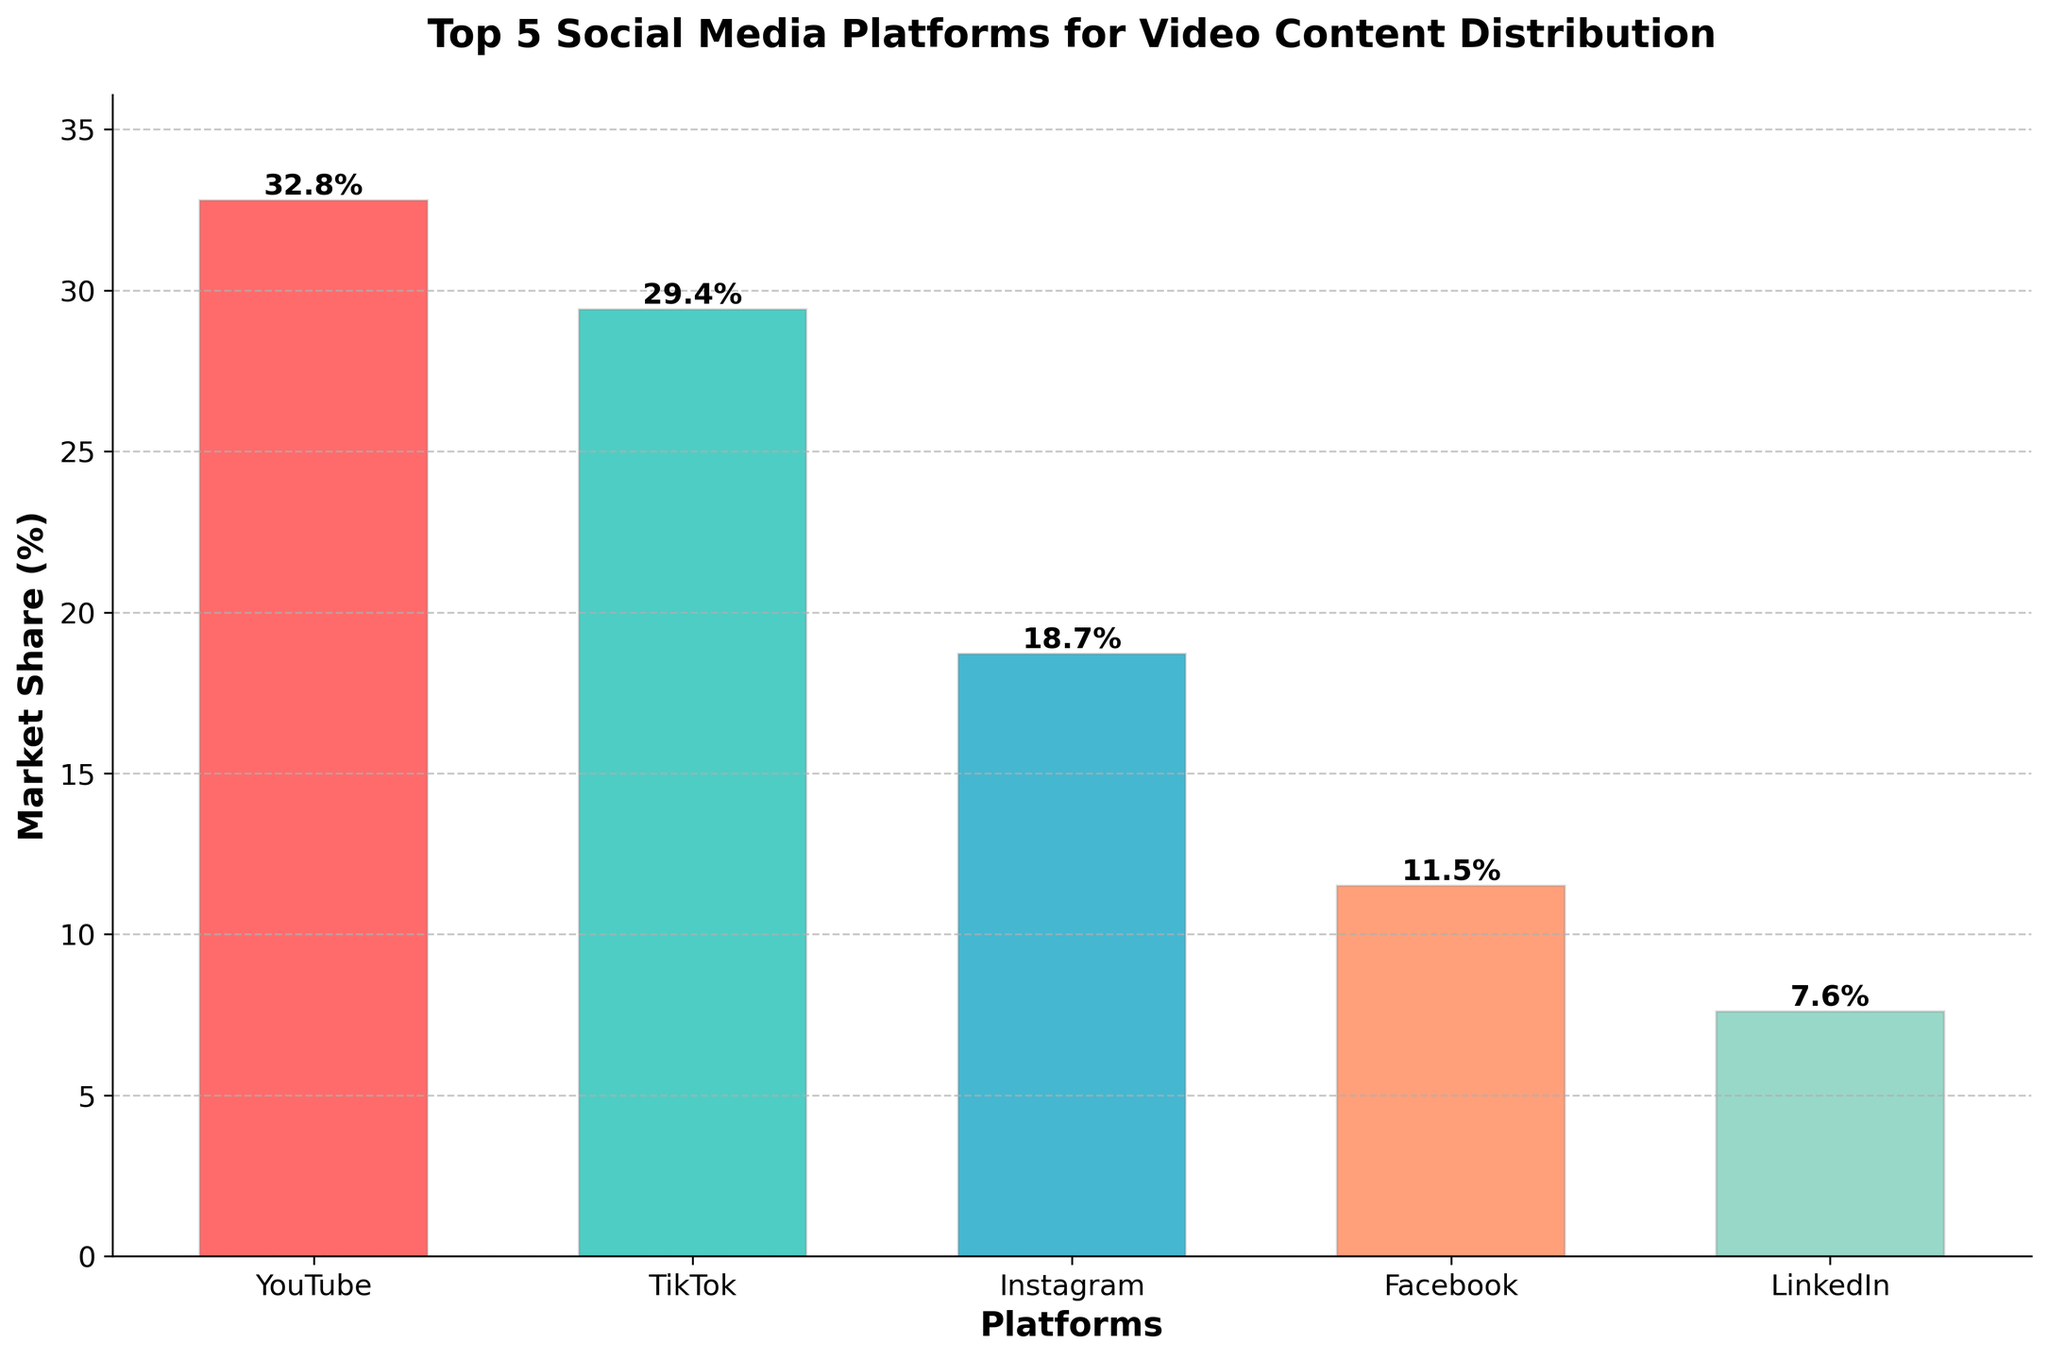What's the total market share of YouTube and TikTok combined? To find the total market share of YouTube and TikTok, add their respective market shares: 32.8% (YouTube) + 29.4% (TikTok) = 62.2%.
Answer: 62.2% Which platform has the lowest market share? From the figure, LinkedIn has the smallest bar, representing the lowest market share of 7.6%.
Answer: LinkedIn What is the difference in market share between the highest and lowest-ranked platforms? The highest market share is 32.8% for YouTube and the lowest is 7.6% for LinkedIn. Subtracting these gives: 32.8% - 7.6% = 25.2%.
Answer: 25.2% Which platform has a higher market share: Instagram or Facebook? By examining the heights of the bars, Instagram with an 18.7% market share is higher than Facebook's 11.5%.
Answer: Instagram What's the average market share of the top 5 platforms? First, sum the market shares: 32.8% (YouTube) + 29.4% (TikTok) + 18.7% (Instagram) + 11.5% (Facebook) + 7.6% (LinkedIn) = 100%. Then divide by the number of platforms: 100% / 5 = 20%.
Answer: 20% What is the combined market share of the platforms with a market share under 20%? The platforms under 20% are: Instagram (18.7%), Facebook (11.5%), and LinkedIn (7.6%). Adding these gives: 18.7% + 11.5% + 7.6% = 37.8%.
Answer: 37.8% Which platform's bar is orange in color? The color scheme shows that the orange bar represents Facebook, with a market share of 11.5%.
Answer: Facebook Is TikTok's market share more or less than 30%? TikTok's market share is 29.4%, which is less than 30%.
Answer: Less Arrange the platforms in descending order of their market share. The market shares in descending order are: YouTube (32.8%), TikTok (29.4%), Instagram (18.7%), Facebook (11.5%), LinkedIn (7.6%).
Answer: YouTube, TikTok, Instagram, Facebook, LinkedIn What's the percentage difference between the market share of Instagram and LinkedIn? The market share of Instagram is 18.7%, and LinkedIn is 7.6%. The percentage difference is 18.7% - 7.6% = 11.1%.
Answer: 11.1% 